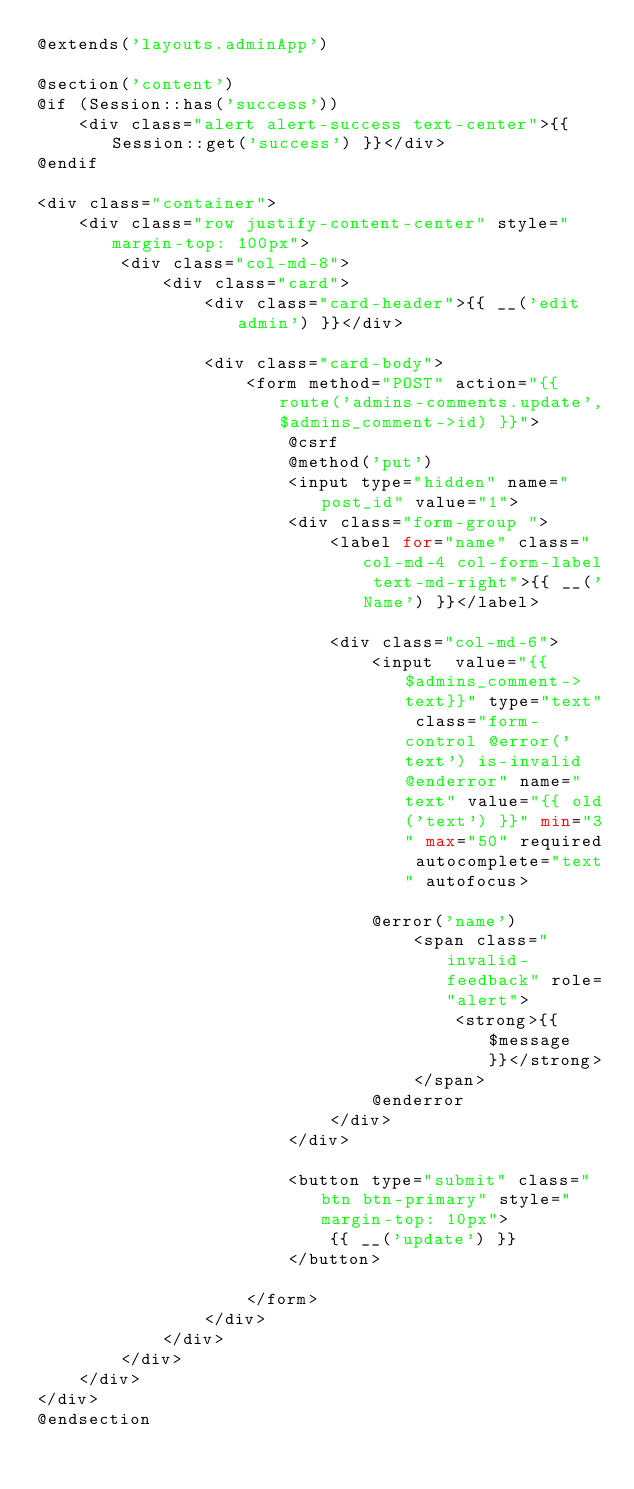<code> <loc_0><loc_0><loc_500><loc_500><_PHP_>@extends('layouts.adminApp')

@section('content')
@if (Session::has('success'))
    <div class="alert alert-success text-center">{{ Session::get('success') }}</div>
@endif

<div class="container">
    <div class="row justify-content-center" style="margin-top: 100px">
        <div class="col-md-8">
            <div class="card">
                <div class="card-header">{{ __('edit admin') }}</div>

                <div class="card-body">
                    <form method="POST" action="{{ route('admins-comments.update',$admins_comment->id) }}">
                        @csrf
                        @method('put')
                        <input type="hidden" name="post_id" value="1">
                        <div class="form-group ">
                            <label for="name" class="col-md-4 col-form-label text-md-right">{{ __('Name') }}</label>

                            <div class="col-md-6">
                                <input  value="{{$admins_comment->text}}" type="text" class="form-control @error('text') is-invalid @enderror" name="text" value="{{ old('text') }}" min="3" max="50" required autocomplete="text" autofocus>

                                @error('name')
                                    <span class="invalid-feedback" role="alert">
                                        <strong>{{ $message }}</strong>
                                    </span>
                                @enderror
                            </div>
                        </div>

                        <button type="submit" class="btn btn-primary" style="margin-top: 10px">
                            {{ __('update') }}
                        </button>

                    </form>
                </div>
            </div>
        </div>
    </div>
</div>
@endsection
</code> 